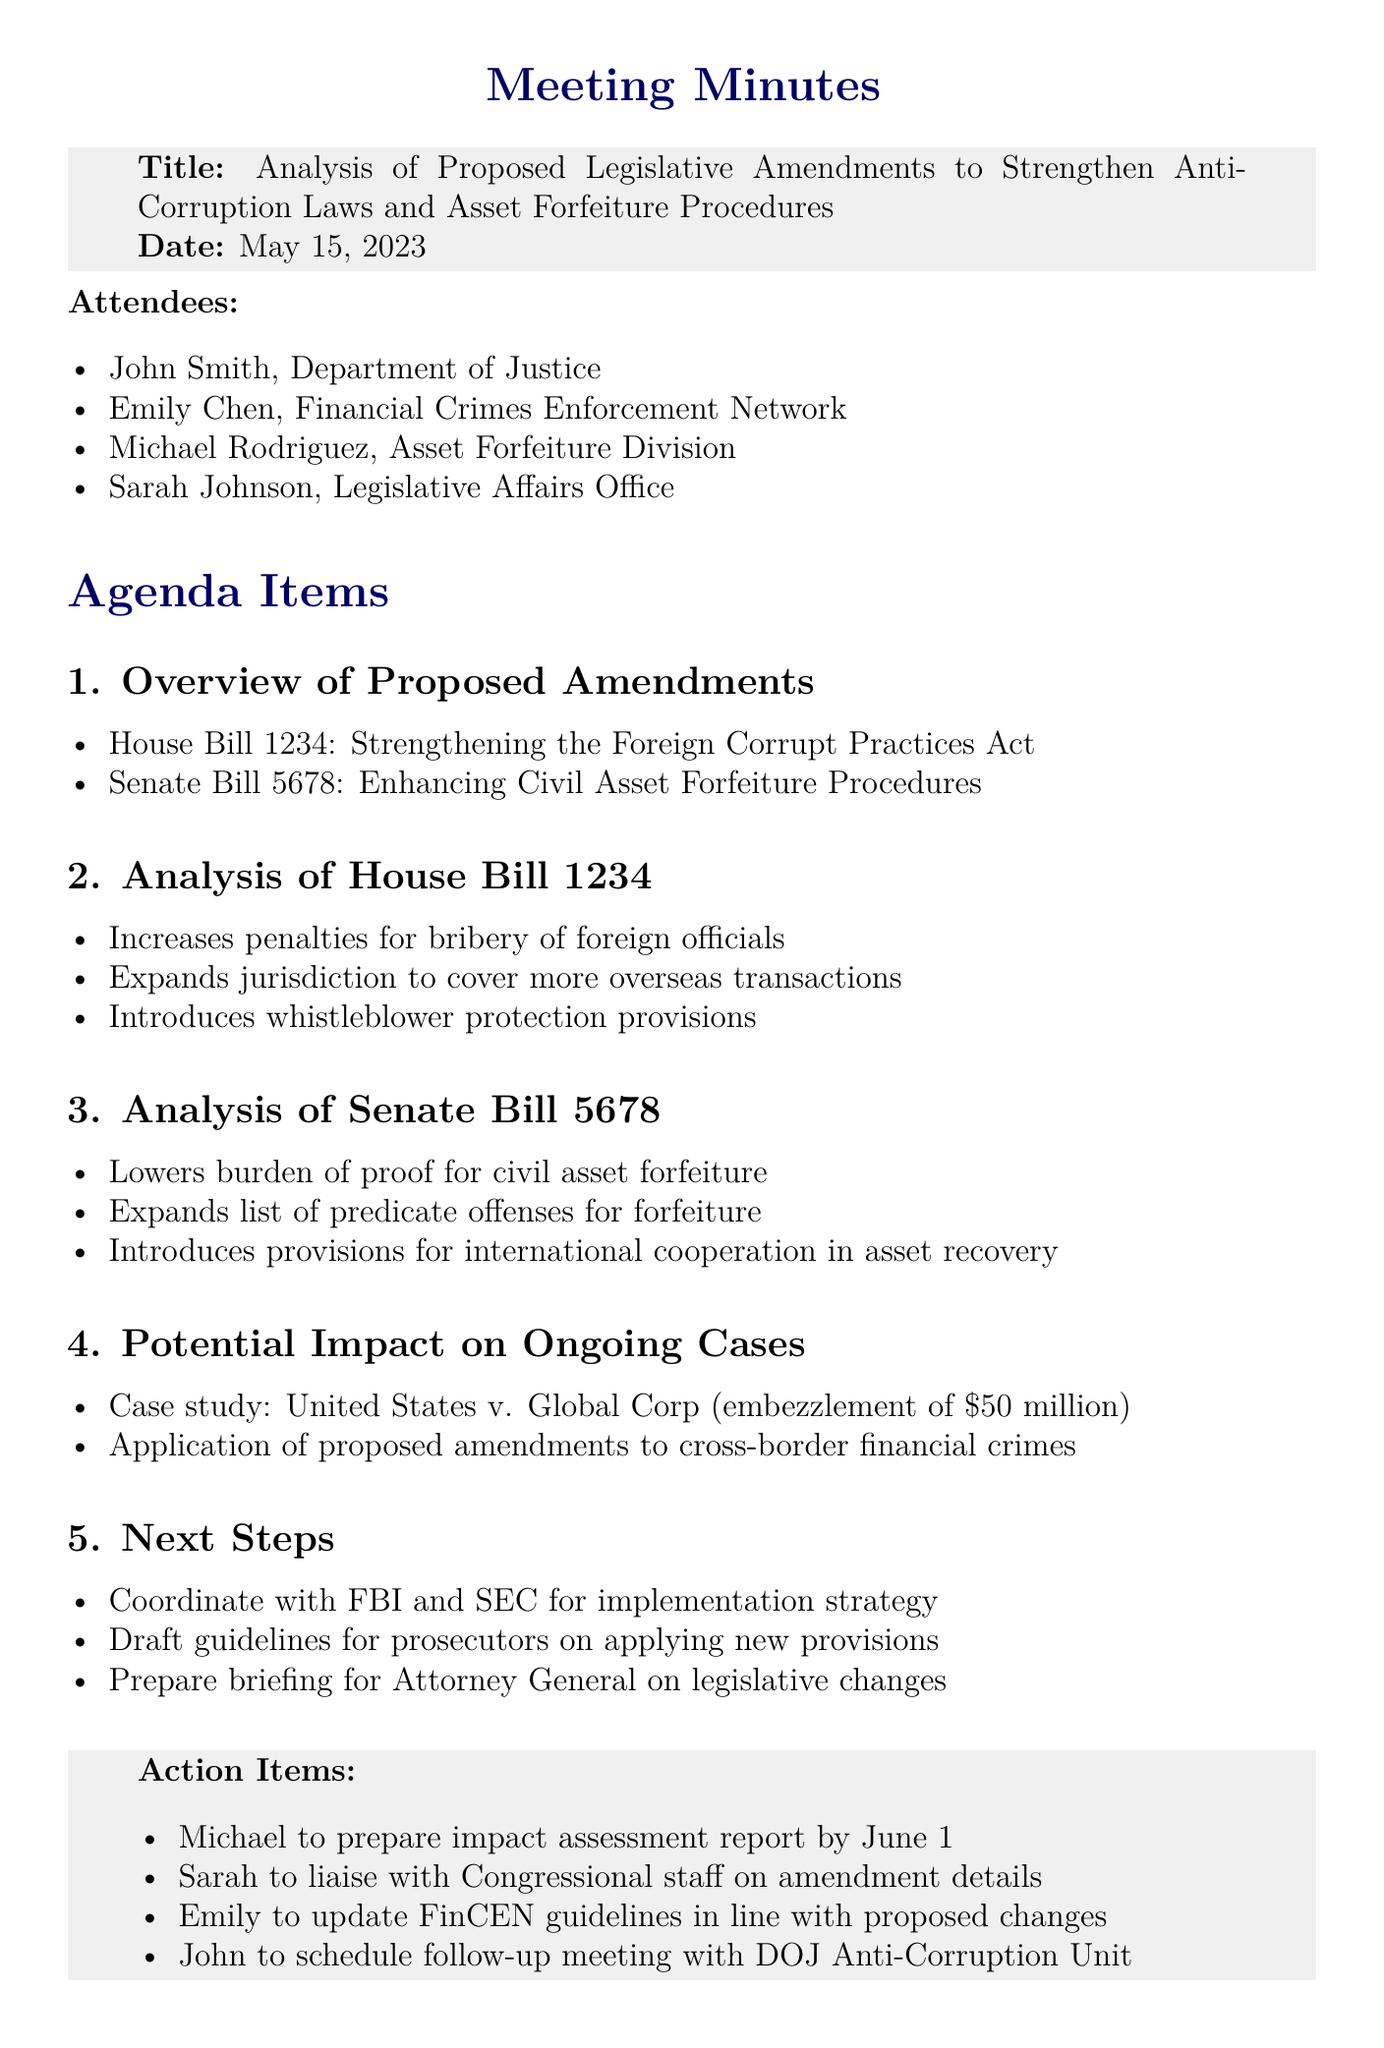What is the meeting date? The meeting took place on May 15, 2023, as stated in the document.
Answer: May 15, 2023 Who is responsible for preparing the impact assessment report? The action items specify that Michael is tasked with this report.
Answer: Michael What is the title of House Bill 1234? The document names this bill focused on strengthening anti-corruption laws.
Answer: Strengthening the Foreign Corrupt Practices Act What is one key provision of Senate Bill 5678? The document lists several provisions, one being the lowering of the burden of proof.
Answer: Lowers burden of proof for civil asset forfeiture How much was embezzled in the case study discussed? The document mentions a specific case involving a $50 million embezzlement.
Answer: $50 million Which federal agency will coordinate for the implementation strategy? The document states coordination will occur with the FBI.
Answer: FBI What is one objective of the proposed legislative amendments? The amendments aim to enhance civil asset forfeiture procedures, as per the agenda items.
Answer: Enhancing Civil Asset Forfeiture Procedures Who will liaise with Congressional staff on the amendment details? The action items indicate that Sarah will handle this task.
Answer: Sarah 